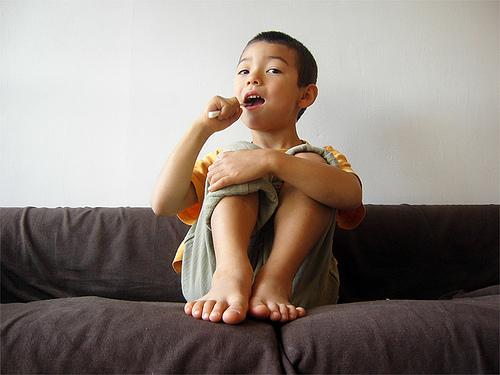Is the child wearing socks?
Concise answer only. No. What color is the toothbrush?
Short answer required. White. Is this photograph taken indoors?
Short answer required. Yes. 